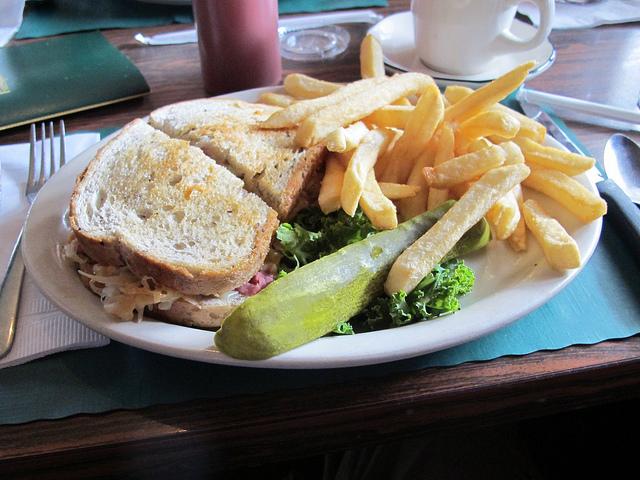Do you see tomatoes in the sandwich?
Keep it brief. No. What is under the pickle?
Give a very brief answer. Lettuce. How many pieces of silverware are there?
Concise answer only. 3. What is the green thing on the sandwich?
Short answer required. Pickle. How many pieces is the sandwich cut into?
Write a very short answer. 2. 